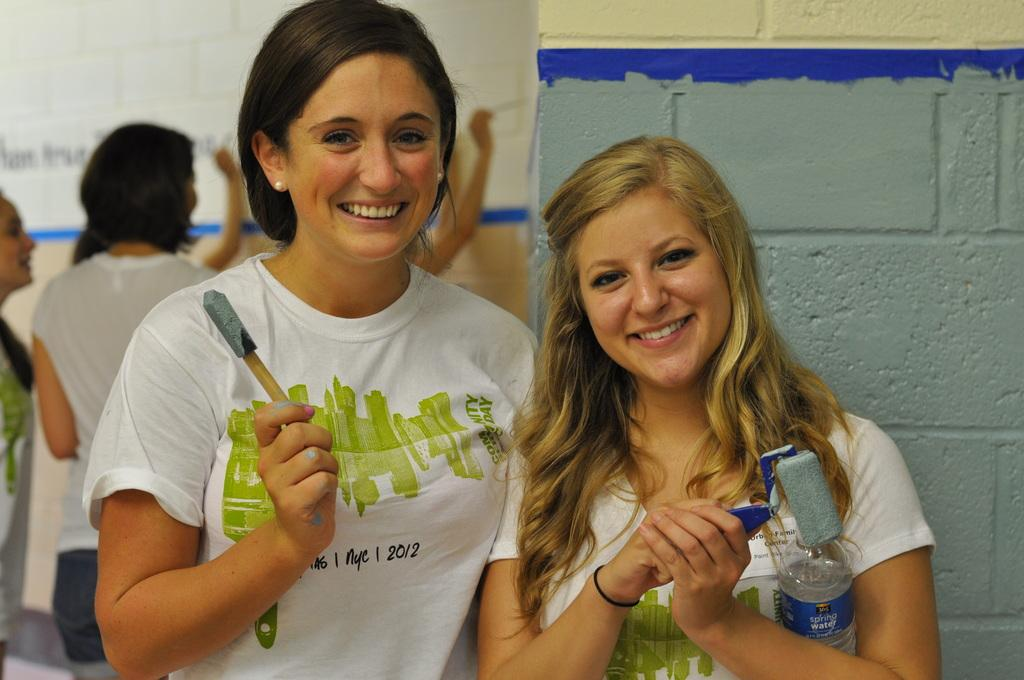How many people are visible in the image? There are two people in the image. What are the two people holding? The two people are holding objects. What is the facial expression of the two people? The two people are smiling. Are there any other people in the image besides the two smiling individuals? Yes, there are a few people behind them. What are the people behind them doing? The people behind them are writing on a wall. What type of grass is being used as a quilt by the women in the image? There are no women or grass present in the image, and therefore no such activity can be observed. 